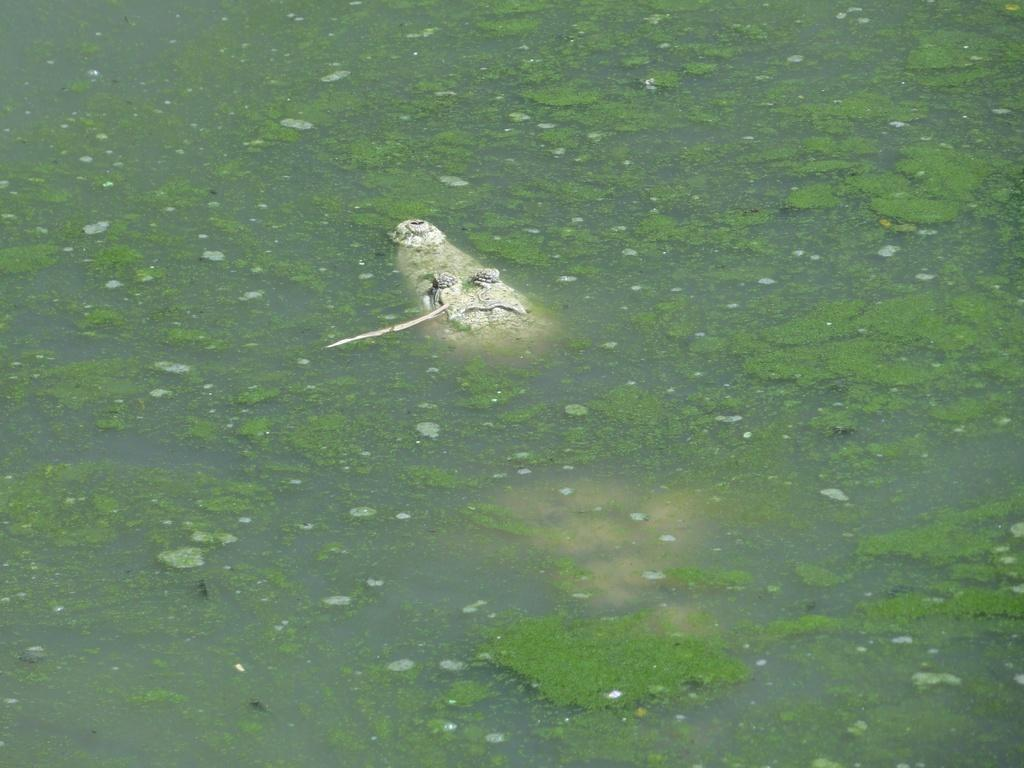What animal is present in the image? There is a crocodile in the image. Where is the crocodile located? The crocodile is in the water. What year is depicted in the image? The image does not depict a specific year; it only shows a crocodile in the water. Can you see the crocodile biting anything in the image? There is no indication in the image that the crocodile is biting anything. 